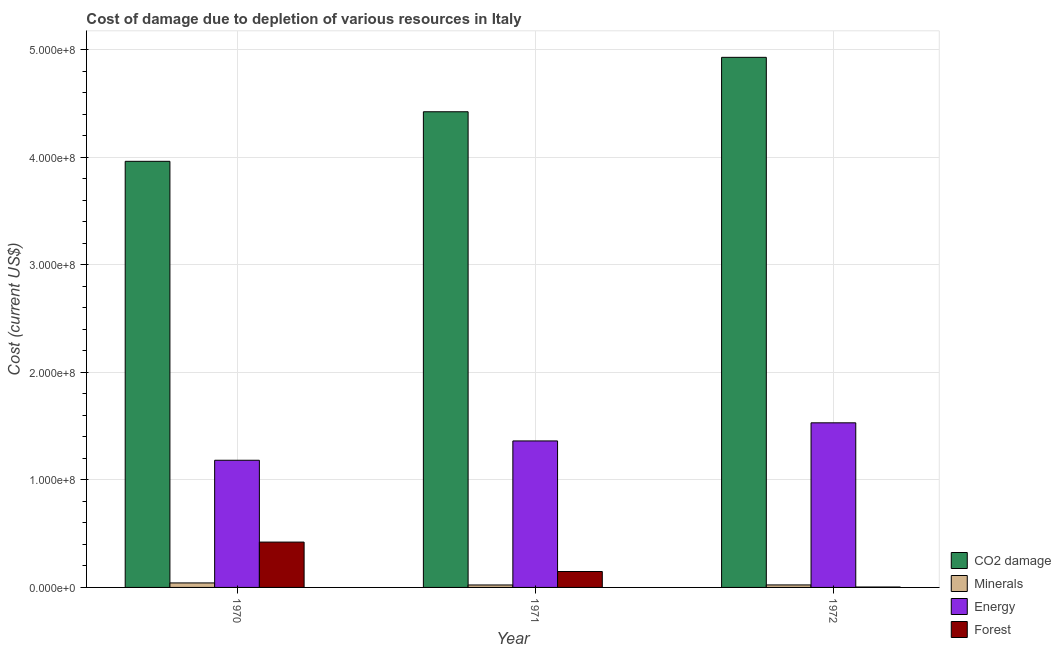How many different coloured bars are there?
Make the answer very short. 4. How many groups of bars are there?
Ensure brevity in your answer.  3. Are the number of bars per tick equal to the number of legend labels?
Provide a short and direct response. Yes. Are the number of bars on each tick of the X-axis equal?
Your answer should be very brief. Yes. How many bars are there on the 3rd tick from the right?
Keep it short and to the point. 4. What is the label of the 2nd group of bars from the left?
Your answer should be very brief. 1971. In how many cases, is the number of bars for a given year not equal to the number of legend labels?
Your response must be concise. 0. What is the cost of damage due to depletion of energy in 1972?
Ensure brevity in your answer.  1.53e+08. Across all years, what is the maximum cost of damage due to depletion of forests?
Provide a short and direct response. 4.22e+07. Across all years, what is the minimum cost of damage due to depletion of coal?
Your answer should be compact. 3.96e+08. In which year was the cost of damage due to depletion of forests maximum?
Make the answer very short. 1970. What is the total cost of damage due to depletion of forests in the graph?
Your answer should be very brief. 5.73e+07. What is the difference between the cost of damage due to depletion of forests in 1970 and that in 1971?
Provide a succinct answer. 2.74e+07. What is the difference between the cost of damage due to depletion of minerals in 1970 and the cost of damage due to depletion of coal in 1972?
Ensure brevity in your answer.  1.86e+06. What is the average cost of damage due to depletion of minerals per year?
Make the answer very short. 2.92e+06. In the year 1971, what is the difference between the cost of damage due to depletion of energy and cost of damage due to depletion of forests?
Provide a succinct answer. 0. In how many years, is the cost of damage due to depletion of coal greater than 420000000 US$?
Make the answer very short. 2. What is the ratio of the cost of damage due to depletion of energy in 1970 to that in 1972?
Your response must be concise. 0.77. What is the difference between the highest and the second highest cost of damage due to depletion of energy?
Provide a short and direct response. 1.68e+07. What is the difference between the highest and the lowest cost of damage due to depletion of minerals?
Make the answer very short. 1.89e+06. In how many years, is the cost of damage due to depletion of energy greater than the average cost of damage due to depletion of energy taken over all years?
Ensure brevity in your answer.  2. Is the sum of the cost of damage due to depletion of minerals in 1971 and 1972 greater than the maximum cost of damage due to depletion of forests across all years?
Keep it short and to the point. Yes. Is it the case that in every year, the sum of the cost of damage due to depletion of coal and cost of damage due to depletion of minerals is greater than the sum of cost of damage due to depletion of forests and cost of damage due to depletion of energy?
Your answer should be compact. Yes. What does the 2nd bar from the left in 1971 represents?
Make the answer very short. Minerals. What does the 4th bar from the right in 1972 represents?
Your answer should be very brief. CO2 damage. How many bars are there?
Offer a terse response. 12. Are the values on the major ticks of Y-axis written in scientific E-notation?
Make the answer very short. Yes. Does the graph contain any zero values?
Ensure brevity in your answer.  No. Does the graph contain grids?
Offer a very short reply. Yes. Where does the legend appear in the graph?
Offer a terse response. Bottom right. How many legend labels are there?
Your answer should be compact. 4. What is the title of the graph?
Your answer should be compact. Cost of damage due to depletion of various resources in Italy . Does "WFP" appear as one of the legend labels in the graph?
Offer a very short reply. No. What is the label or title of the Y-axis?
Make the answer very short. Cost (current US$). What is the Cost (current US$) in CO2 damage in 1970?
Provide a short and direct response. 3.96e+08. What is the Cost (current US$) in Minerals in 1970?
Make the answer very short. 4.17e+06. What is the Cost (current US$) of Energy in 1970?
Keep it short and to the point. 1.18e+08. What is the Cost (current US$) in Forest in 1970?
Give a very brief answer. 4.22e+07. What is the Cost (current US$) of CO2 damage in 1971?
Provide a short and direct response. 4.42e+08. What is the Cost (current US$) of Minerals in 1971?
Ensure brevity in your answer.  2.28e+06. What is the Cost (current US$) in Energy in 1971?
Your answer should be compact. 1.36e+08. What is the Cost (current US$) of Forest in 1971?
Offer a very short reply. 1.48e+07. What is the Cost (current US$) in CO2 damage in 1972?
Offer a very short reply. 4.93e+08. What is the Cost (current US$) of Minerals in 1972?
Offer a very short reply. 2.32e+06. What is the Cost (current US$) in Energy in 1972?
Your answer should be compact. 1.53e+08. What is the Cost (current US$) in Forest in 1972?
Provide a short and direct response. 3.87e+05. Across all years, what is the maximum Cost (current US$) of CO2 damage?
Your answer should be very brief. 4.93e+08. Across all years, what is the maximum Cost (current US$) of Minerals?
Ensure brevity in your answer.  4.17e+06. Across all years, what is the maximum Cost (current US$) in Energy?
Provide a short and direct response. 1.53e+08. Across all years, what is the maximum Cost (current US$) of Forest?
Ensure brevity in your answer.  4.22e+07. Across all years, what is the minimum Cost (current US$) of CO2 damage?
Your answer should be compact. 3.96e+08. Across all years, what is the minimum Cost (current US$) in Minerals?
Your answer should be very brief. 2.28e+06. Across all years, what is the minimum Cost (current US$) of Energy?
Keep it short and to the point. 1.18e+08. Across all years, what is the minimum Cost (current US$) in Forest?
Make the answer very short. 3.87e+05. What is the total Cost (current US$) of CO2 damage in the graph?
Give a very brief answer. 1.33e+09. What is the total Cost (current US$) of Minerals in the graph?
Your response must be concise. 8.77e+06. What is the total Cost (current US$) of Energy in the graph?
Offer a terse response. 4.07e+08. What is the total Cost (current US$) of Forest in the graph?
Make the answer very short. 5.73e+07. What is the difference between the Cost (current US$) in CO2 damage in 1970 and that in 1971?
Give a very brief answer. -4.61e+07. What is the difference between the Cost (current US$) of Minerals in 1970 and that in 1971?
Your response must be concise. 1.89e+06. What is the difference between the Cost (current US$) in Energy in 1970 and that in 1971?
Provide a short and direct response. -1.80e+07. What is the difference between the Cost (current US$) in Forest in 1970 and that in 1971?
Offer a very short reply. 2.74e+07. What is the difference between the Cost (current US$) of CO2 damage in 1970 and that in 1972?
Offer a terse response. -9.67e+07. What is the difference between the Cost (current US$) in Minerals in 1970 and that in 1972?
Your answer should be very brief. 1.86e+06. What is the difference between the Cost (current US$) in Energy in 1970 and that in 1972?
Provide a short and direct response. -3.48e+07. What is the difference between the Cost (current US$) of Forest in 1970 and that in 1972?
Your answer should be very brief. 4.18e+07. What is the difference between the Cost (current US$) of CO2 damage in 1971 and that in 1972?
Keep it short and to the point. -5.06e+07. What is the difference between the Cost (current US$) of Minerals in 1971 and that in 1972?
Provide a short and direct response. -3.72e+04. What is the difference between the Cost (current US$) of Energy in 1971 and that in 1972?
Make the answer very short. -1.68e+07. What is the difference between the Cost (current US$) of Forest in 1971 and that in 1972?
Give a very brief answer. 1.44e+07. What is the difference between the Cost (current US$) in CO2 damage in 1970 and the Cost (current US$) in Minerals in 1971?
Ensure brevity in your answer.  3.94e+08. What is the difference between the Cost (current US$) in CO2 damage in 1970 and the Cost (current US$) in Energy in 1971?
Your answer should be very brief. 2.60e+08. What is the difference between the Cost (current US$) of CO2 damage in 1970 and the Cost (current US$) of Forest in 1971?
Your answer should be very brief. 3.81e+08. What is the difference between the Cost (current US$) in Minerals in 1970 and the Cost (current US$) in Energy in 1971?
Your response must be concise. -1.32e+08. What is the difference between the Cost (current US$) in Minerals in 1970 and the Cost (current US$) in Forest in 1971?
Offer a very short reply. -1.06e+07. What is the difference between the Cost (current US$) of Energy in 1970 and the Cost (current US$) of Forest in 1971?
Your answer should be compact. 1.03e+08. What is the difference between the Cost (current US$) in CO2 damage in 1970 and the Cost (current US$) in Minerals in 1972?
Keep it short and to the point. 3.94e+08. What is the difference between the Cost (current US$) in CO2 damage in 1970 and the Cost (current US$) in Energy in 1972?
Provide a short and direct response. 2.43e+08. What is the difference between the Cost (current US$) in CO2 damage in 1970 and the Cost (current US$) in Forest in 1972?
Your answer should be very brief. 3.96e+08. What is the difference between the Cost (current US$) of Minerals in 1970 and the Cost (current US$) of Energy in 1972?
Your response must be concise. -1.49e+08. What is the difference between the Cost (current US$) of Minerals in 1970 and the Cost (current US$) of Forest in 1972?
Offer a terse response. 3.79e+06. What is the difference between the Cost (current US$) of Energy in 1970 and the Cost (current US$) of Forest in 1972?
Give a very brief answer. 1.18e+08. What is the difference between the Cost (current US$) in CO2 damage in 1971 and the Cost (current US$) in Minerals in 1972?
Make the answer very short. 4.40e+08. What is the difference between the Cost (current US$) of CO2 damage in 1971 and the Cost (current US$) of Energy in 1972?
Ensure brevity in your answer.  2.89e+08. What is the difference between the Cost (current US$) in CO2 damage in 1971 and the Cost (current US$) in Forest in 1972?
Your answer should be compact. 4.42e+08. What is the difference between the Cost (current US$) in Minerals in 1971 and the Cost (current US$) in Energy in 1972?
Ensure brevity in your answer.  -1.51e+08. What is the difference between the Cost (current US$) in Minerals in 1971 and the Cost (current US$) in Forest in 1972?
Offer a terse response. 1.89e+06. What is the difference between the Cost (current US$) in Energy in 1971 and the Cost (current US$) in Forest in 1972?
Give a very brief answer. 1.36e+08. What is the average Cost (current US$) of CO2 damage per year?
Your answer should be compact. 4.44e+08. What is the average Cost (current US$) of Minerals per year?
Provide a succinct answer. 2.92e+06. What is the average Cost (current US$) in Energy per year?
Offer a very short reply. 1.36e+08. What is the average Cost (current US$) in Forest per year?
Offer a terse response. 1.91e+07. In the year 1970, what is the difference between the Cost (current US$) of CO2 damage and Cost (current US$) of Minerals?
Offer a terse response. 3.92e+08. In the year 1970, what is the difference between the Cost (current US$) in CO2 damage and Cost (current US$) in Energy?
Provide a short and direct response. 2.78e+08. In the year 1970, what is the difference between the Cost (current US$) in CO2 damage and Cost (current US$) in Forest?
Offer a terse response. 3.54e+08. In the year 1970, what is the difference between the Cost (current US$) of Minerals and Cost (current US$) of Energy?
Keep it short and to the point. -1.14e+08. In the year 1970, what is the difference between the Cost (current US$) in Minerals and Cost (current US$) in Forest?
Your answer should be very brief. -3.80e+07. In the year 1970, what is the difference between the Cost (current US$) in Energy and Cost (current US$) in Forest?
Keep it short and to the point. 7.61e+07. In the year 1971, what is the difference between the Cost (current US$) of CO2 damage and Cost (current US$) of Minerals?
Keep it short and to the point. 4.40e+08. In the year 1971, what is the difference between the Cost (current US$) of CO2 damage and Cost (current US$) of Energy?
Your answer should be very brief. 3.06e+08. In the year 1971, what is the difference between the Cost (current US$) of CO2 damage and Cost (current US$) of Forest?
Your response must be concise. 4.27e+08. In the year 1971, what is the difference between the Cost (current US$) in Minerals and Cost (current US$) in Energy?
Provide a short and direct response. -1.34e+08. In the year 1971, what is the difference between the Cost (current US$) of Minerals and Cost (current US$) of Forest?
Your answer should be very brief. -1.25e+07. In the year 1971, what is the difference between the Cost (current US$) of Energy and Cost (current US$) of Forest?
Give a very brief answer. 1.21e+08. In the year 1972, what is the difference between the Cost (current US$) of CO2 damage and Cost (current US$) of Minerals?
Your response must be concise. 4.90e+08. In the year 1972, what is the difference between the Cost (current US$) of CO2 damage and Cost (current US$) of Energy?
Provide a short and direct response. 3.40e+08. In the year 1972, what is the difference between the Cost (current US$) in CO2 damage and Cost (current US$) in Forest?
Provide a succinct answer. 4.92e+08. In the year 1972, what is the difference between the Cost (current US$) of Minerals and Cost (current US$) of Energy?
Provide a succinct answer. -1.51e+08. In the year 1972, what is the difference between the Cost (current US$) in Minerals and Cost (current US$) in Forest?
Ensure brevity in your answer.  1.93e+06. In the year 1972, what is the difference between the Cost (current US$) in Energy and Cost (current US$) in Forest?
Give a very brief answer. 1.53e+08. What is the ratio of the Cost (current US$) of CO2 damage in 1970 to that in 1971?
Offer a very short reply. 0.9. What is the ratio of the Cost (current US$) of Minerals in 1970 to that in 1971?
Your response must be concise. 1.83. What is the ratio of the Cost (current US$) of Energy in 1970 to that in 1971?
Offer a terse response. 0.87. What is the ratio of the Cost (current US$) in Forest in 1970 to that in 1971?
Your response must be concise. 2.85. What is the ratio of the Cost (current US$) of CO2 damage in 1970 to that in 1972?
Give a very brief answer. 0.8. What is the ratio of the Cost (current US$) in Minerals in 1970 to that in 1972?
Make the answer very short. 1.8. What is the ratio of the Cost (current US$) of Energy in 1970 to that in 1972?
Provide a succinct answer. 0.77. What is the ratio of the Cost (current US$) of Forest in 1970 to that in 1972?
Offer a terse response. 108.87. What is the ratio of the Cost (current US$) in CO2 damage in 1971 to that in 1972?
Your answer should be compact. 0.9. What is the ratio of the Cost (current US$) in Minerals in 1971 to that in 1972?
Keep it short and to the point. 0.98. What is the ratio of the Cost (current US$) of Energy in 1971 to that in 1972?
Your answer should be compact. 0.89. What is the ratio of the Cost (current US$) of Forest in 1971 to that in 1972?
Keep it short and to the point. 38.2. What is the difference between the highest and the second highest Cost (current US$) of CO2 damage?
Ensure brevity in your answer.  5.06e+07. What is the difference between the highest and the second highest Cost (current US$) in Minerals?
Ensure brevity in your answer.  1.86e+06. What is the difference between the highest and the second highest Cost (current US$) in Energy?
Your response must be concise. 1.68e+07. What is the difference between the highest and the second highest Cost (current US$) of Forest?
Ensure brevity in your answer.  2.74e+07. What is the difference between the highest and the lowest Cost (current US$) in CO2 damage?
Make the answer very short. 9.67e+07. What is the difference between the highest and the lowest Cost (current US$) in Minerals?
Your answer should be very brief. 1.89e+06. What is the difference between the highest and the lowest Cost (current US$) of Energy?
Ensure brevity in your answer.  3.48e+07. What is the difference between the highest and the lowest Cost (current US$) of Forest?
Provide a short and direct response. 4.18e+07. 